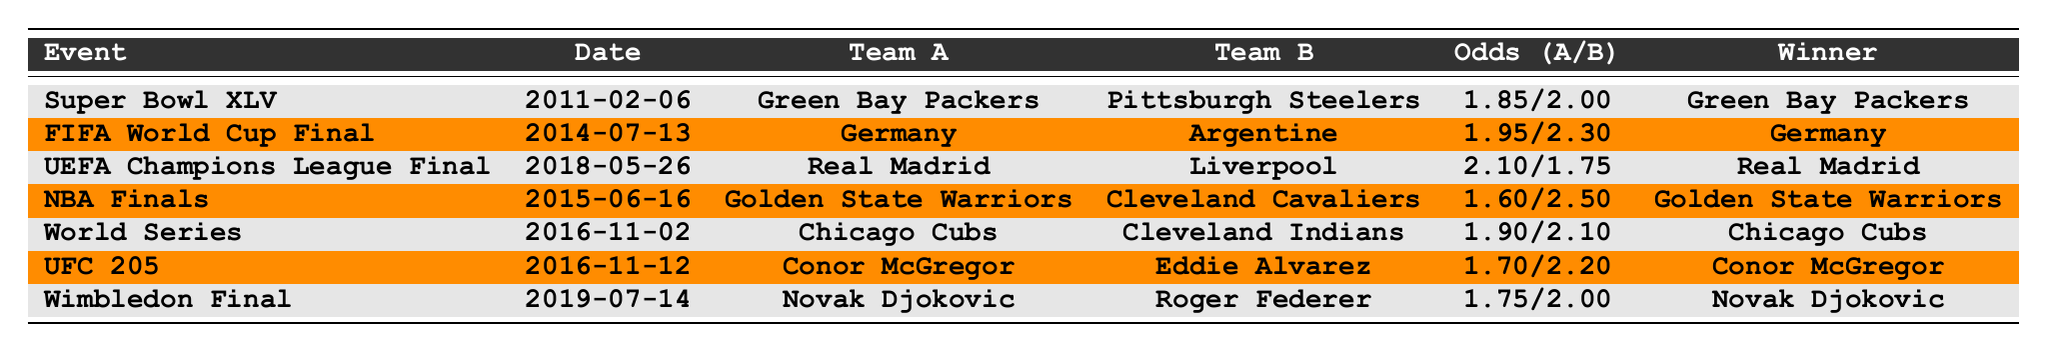What was the winning team in the Super Bowl XLV? The Super Bowl XLV, held on February 6, 2011, had the Green Bay Packers as the winning team. This is directly stated in the table.
Answer: Green Bay Packers Which fighter won the UFC 205 event? According to the table, Conor McGregor won the UFC 205 event that took place on November 12, 2016.
Answer: Conor McGregor What were the odds for the Golden State Warriors in the NBA Finals? The table shows that the odds for the Golden State Warriors in the NBA Finals held on June 16, 2015, were 1.60.
Answer: 1.60 Which event had the closest odds between the two teams? By examining the odds, the closest match was in the Super Bowl XLV, with odds of 1.85 for the Packers and 2.00 for the Steelers, which gives a difference of 0.15.
Answer: Super Bowl XLV What is the average odds for Team A across all events listed? To compute the average odds for Team A, sum the odds: 1.85 + 1.95 + 2.10 + 1.60 + 1.90 + 1.70 + 1.75 = 12.85. There are 7 events, so the average is 12.85 / 7 = 1.83.
Answer: 1.83 Did the Chicago Cubs win the World Series as the favored team? The Chicago Cubs had odds of 1.90, which indicates they were favored over the Cleveland Indians at 2.10. They did win, confirming that the favored team prevailed.
Answer: Yes Which event had the highest odds for the winning team? From the table, the UEFA Champions League Final had the highest odds for Real Madrid at 2.10.
Answer: UEFA Champions League Final In how many events did the team with lower odds lose? The table indicates that in events where team B had lower odds, such as in the Super Bowl XLV and the World Series, team B lost. In total, this occurred in two events.
Answer: 2 What is the difference in odds between Team A and Team B in the Wimbledon Final? For the Wimbledon Final, Novak Djokovic had odds of 1.75 and Roger Federer had odds of 2.00. The difference is 2.00 - 1.75 = 0.25.
Answer: 0.25 Which team was the underdog in the NBA Finals based on the odds? The Cleveland Cavaliers had odds of 2.50, indicating they were the underdog compared to the Golden State Warriors' 1.60.
Answer: Cleveland Cavaliers 